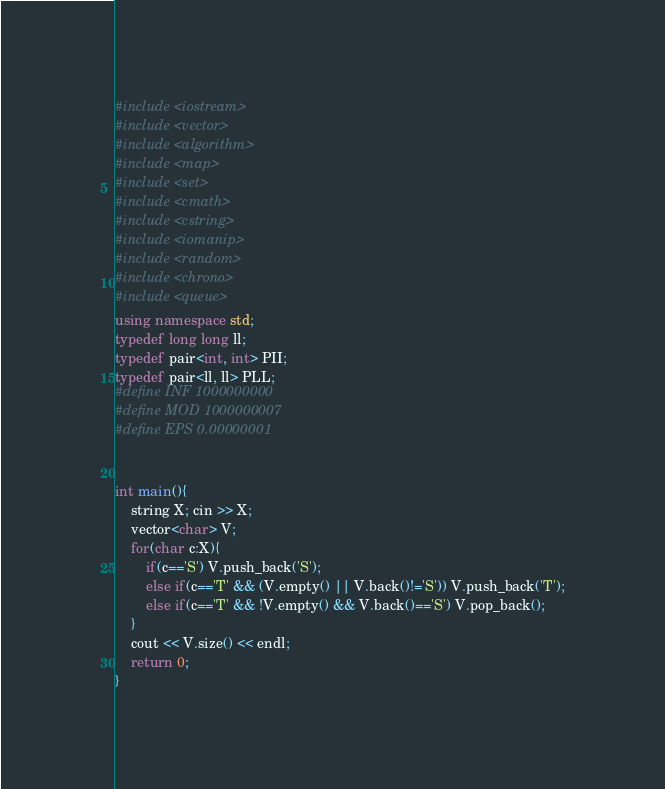<code> <loc_0><loc_0><loc_500><loc_500><_C++_>#include <iostream>
#include <vector>
#include <algorithm>
#include <map>
#include <set>
#include <cmath>
#include <cstring>
#include <iomanip>
#include <random>
#include <chrono>
#include <queue>
using namespace std;
typedef long long ll;
typedef pair<int, int> PII;
typedef pair<ll, ll> PLL;
#define INF 1000000000
#define MOD 1000000007
#define EPS 0.00000001


int main(){
    string X; cin >> X;
    vector<char> V;
    for(char c:X){
        if(c=='S') V.push_back('S');
        else if(c=='T' && (V.empty() || V.back()!='S')) V.push_back('T');
        else if(c=='T' && !V.empty() && V.back()=='S') V.pop_back();
    }
    cout << V.size() << endl;
    return 0;
}
</code> 